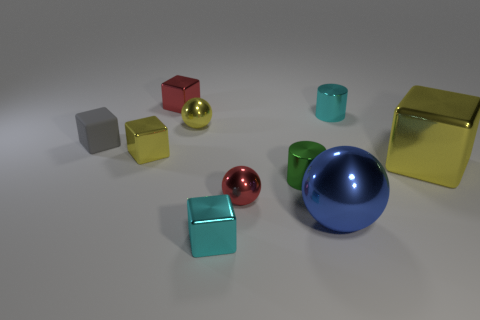Subtract all gray matte cubes. How many cubes are left? 4 Subtract 3 blocks. How many blocks are left? 2 Subtract all red blocks. How many blocks are left? 4 Subtract all blue cubes. Subtract all purple balls. How many cubes are left? 5 Subtract all cylinders. How many objects are left? 8 Add 2 yellow metallic things. How many yellow metallic things are left? 5 Add 1 small green objects. How many small green objects exist? 2 Subtract 0 green blocks. How many objects are left? 10 Subtract all small cyan shiny blocks. Subtract all large metallic spheres. How many objects are left? 8 